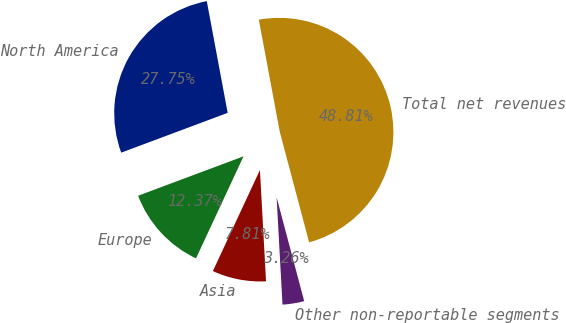Convert chart to OTSL. <chart><loc_0><loc_0><loc_500><loc_500><pie_chart><fcel>North America<fcel>Europe<fcel>Asia<fcel>Other non-reportable segments<fcel>Total net revenues<nl><fcel>27.75%<fcel>12.37%<fcel>7.81%<fcel>3.26%<fcel>48.81%<nl></chart> 